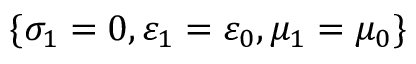Convert formula to latex. <formula><loc_0><loc_0><loc_500><loc_500>\{ \sigma _ { 1 } = 0 , \varepsilon _ { 1 } = \varepsilon _ { 0 } , \mu _ { 1 } = \mu _ { 0 } \}</formula> 